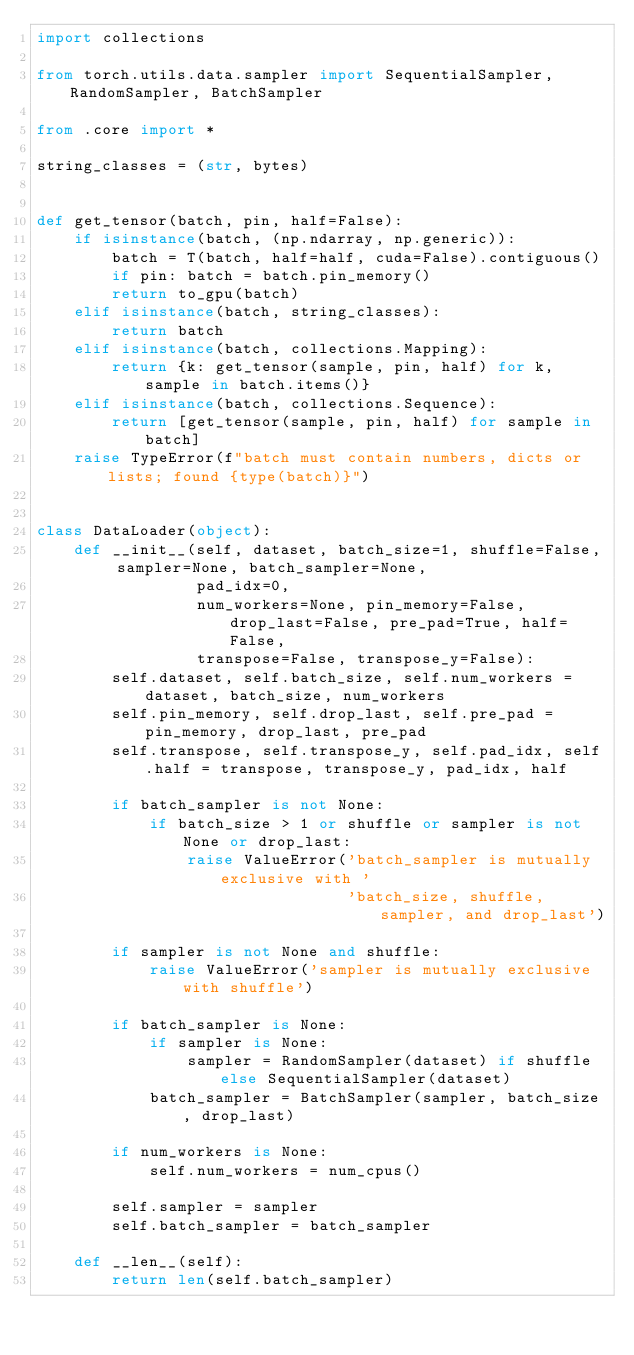<code> <loc_0><loc_0><loc_500><loc_500><_Python_>import collections

from torch.utils.data.sampler import SequentialSampler, RandomSampler, BatchSampler

from .core import *

string_classes = (str, bytes)


def get_tensor(batch, pin, half=False):
    if isinstance(batch, (np.ndarray, np.generic)):
        batch = T(batch, half=half, cuda=False).contiguous()
        if pin: batch = batch.pin_memory()
        return to_gpu(batch)
    elif isinstance(batch, string_classes):
        return batch
    elif isinstance(batch, collections.Mapping):
        return {k: get_tensor(sample, pin, half) for k, sample in batch.items()}
    elif isinstance(batch, collections.Sequence):
        return [get_tensor(sample, pin, half) for sample in batch]
    raise TypeError(f"batch must contain numbers, dicts or lists; found {type(batch)}")


class DataLoader(object):
    def __init__(self, dataset, batch_size=1, shuffle=False, sampler=None, batch_sampler=None,
                 pad_idx=0,
                 num_workers=None, pin_memory=False, drop_last=False, pre_pad=True, half=False,
                 transpose=False, transpose_y=False):
        self.dataset, self.batch_size, self.num_workers = dataset, batch_size, num_workers
        self.pin_memory, self.drop_last, self.pre_pad = pin_memory, drop_last, pre_pad
        self.transpose, self.transpose_y, self.pad_idx, self.half = transpose, transpose_y, pad_idx, half

        if batch_sampler is not None:
            if batch_size > 1 or shuffle or sampler is not None or drop_last:
                raise ValueError('batch_sampler is mutually exclusive with '
                                 'batch_size, shuffle, sampler, and drop_last')

        if sampler is not None and shuffle:
            raise ValueError('sampler is mutually exclusive with shuffle')

        if batch_sampler is None:
            if sampler is None:
                sampler = RandomSampler(dataset) if shuffle else SequentialSampler(dataset)
            batch_sampler = BatchSampler(sampler, batch_size, drop_last)

        if num_workers is None:
            self.num_workers = num_cpus()

        self.sampler = sampler
        self.batch_sampler = batch_sampler

    def __len__(self):
        return len(self.batch_sampler)
</code> 